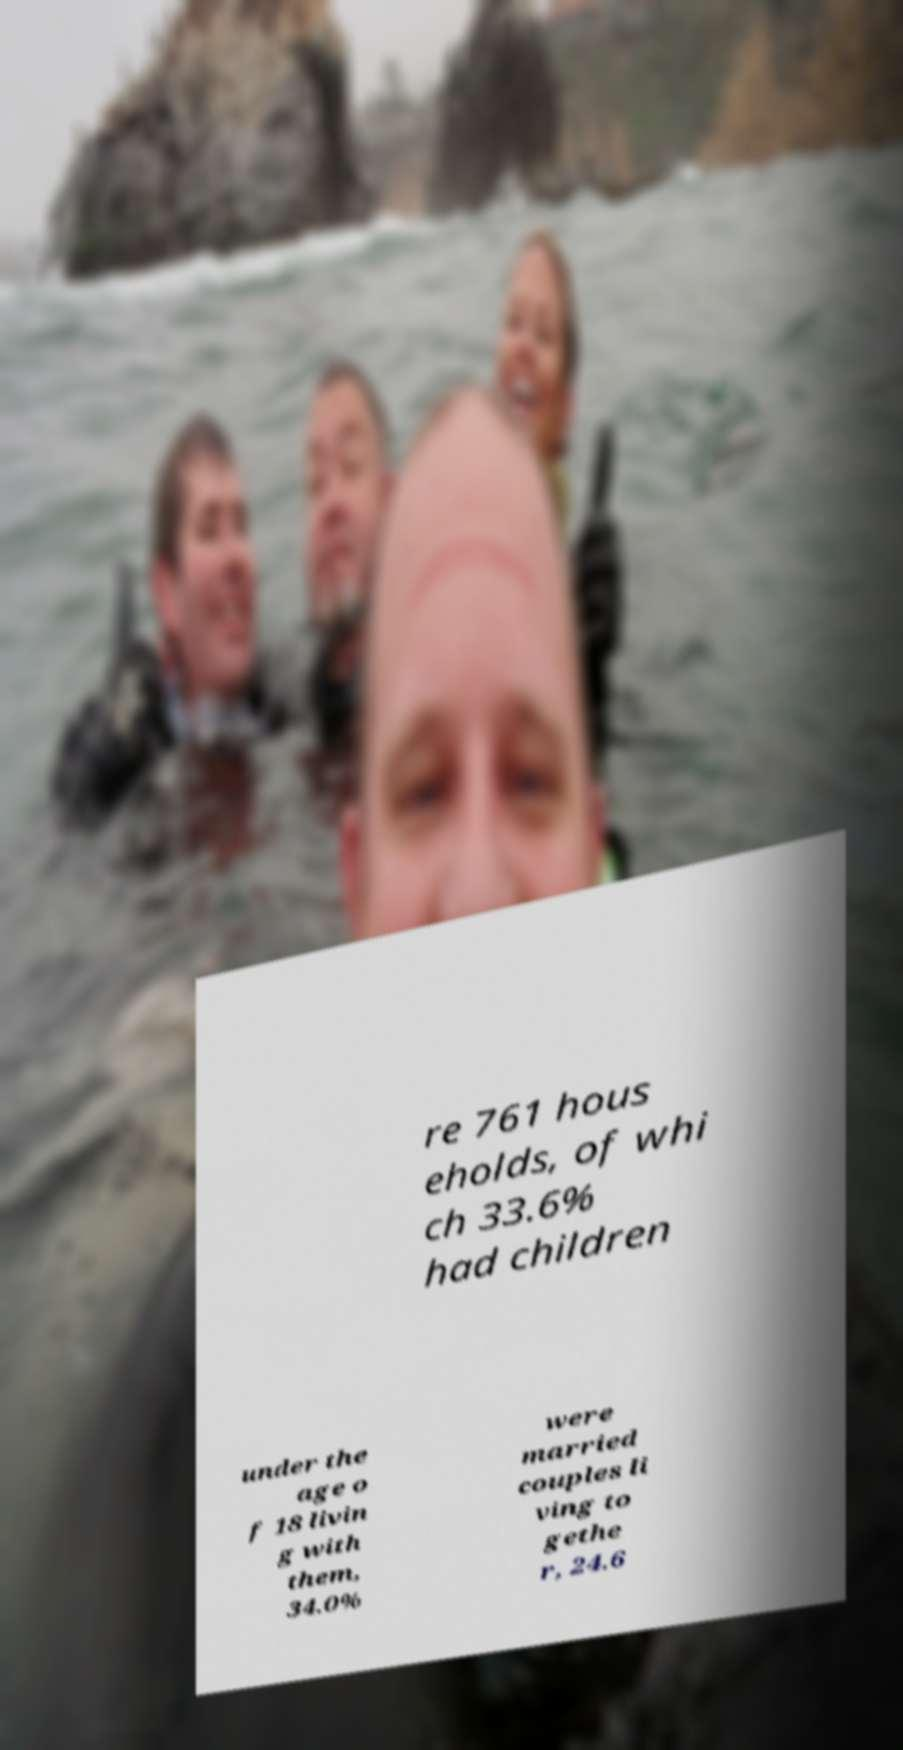Can you accurately transcribe the text from the provided image for me? re 761 hous eholds, of whi ch 33.6% had children under the age o f 18 livin g with them, 34.0% were married couples li ving to gethe r, 24.6 